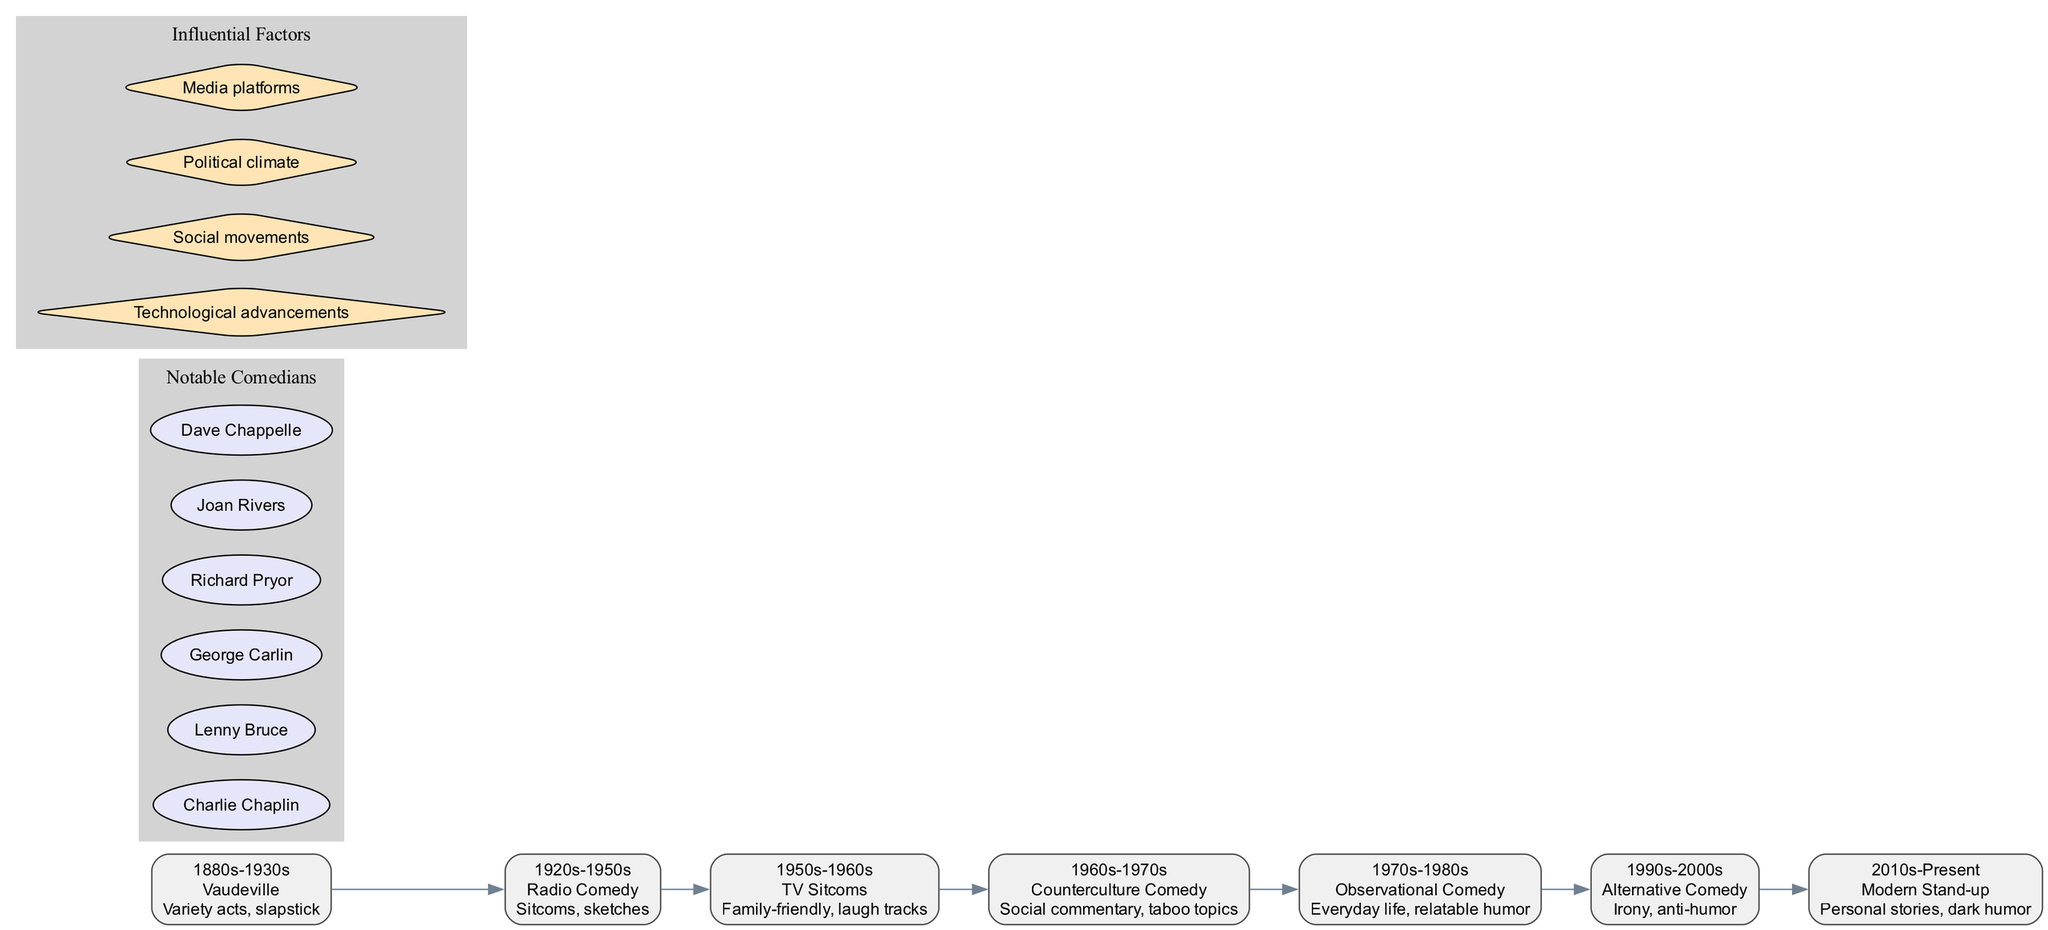What era does Vaudeville belong to? Look at the timeline nodes; Vaudeville is listed with the era "1880s-1930s".
Answer: 1880s-1930s What are the key features of Counterculture Comedy? Find the node for Counterculture Comedy on the timeline and read the corresponding key features. It states "Social commentary, taboo topics".
Answer: Social commentary, taboo topics How many notable comedians are shown in the diagram? Count the number of nodes under the "Notable Comedians" section in the diagram. There are six notable comedians listed.
Answer: 6 Which comedy style is characterized by "Everyday life, relatable humor"? Identify the description for each node on the timeline. The style with those key features is "Observational Comedy".
Answer: Observational Comedy What influenced the evolution of comedy styles according to the diagram? Look at the "Influential Factors" section in the diagram. The factors listed include “Technological advancements, Social movements, Political climate, Media platforms.”
Answer: Technological advancements, Social movements, Political climate, Media platforms What is the relationship between Observational Comedy and Alternative Comedy in the timeline? Observational Comedy is connected directly before Alternative Comedy in the timeline, showing the order of evolution where Observational Comedy comes first before the next style, Alternative Comedy.
Answer: Sequential Which era does Modern Stand-up belong to? Locate Modern Stand-up in the timeline nodes. It is associated with the era "2010s-Present".
Answer: 2010s-Present What are the notable comedians listed in connection with the timeline? Examine the "Notable Comedians" section and name one of the comedians. For example, "Richard Pryor".
Answer: Richard Pryor How does the timeline display the evolution of comedy styles? The timeline uses a chronological layout to show how each style developed from one era to the next, visually indicating the progression and relationship of styles over time.
Answer: Chronological layout 